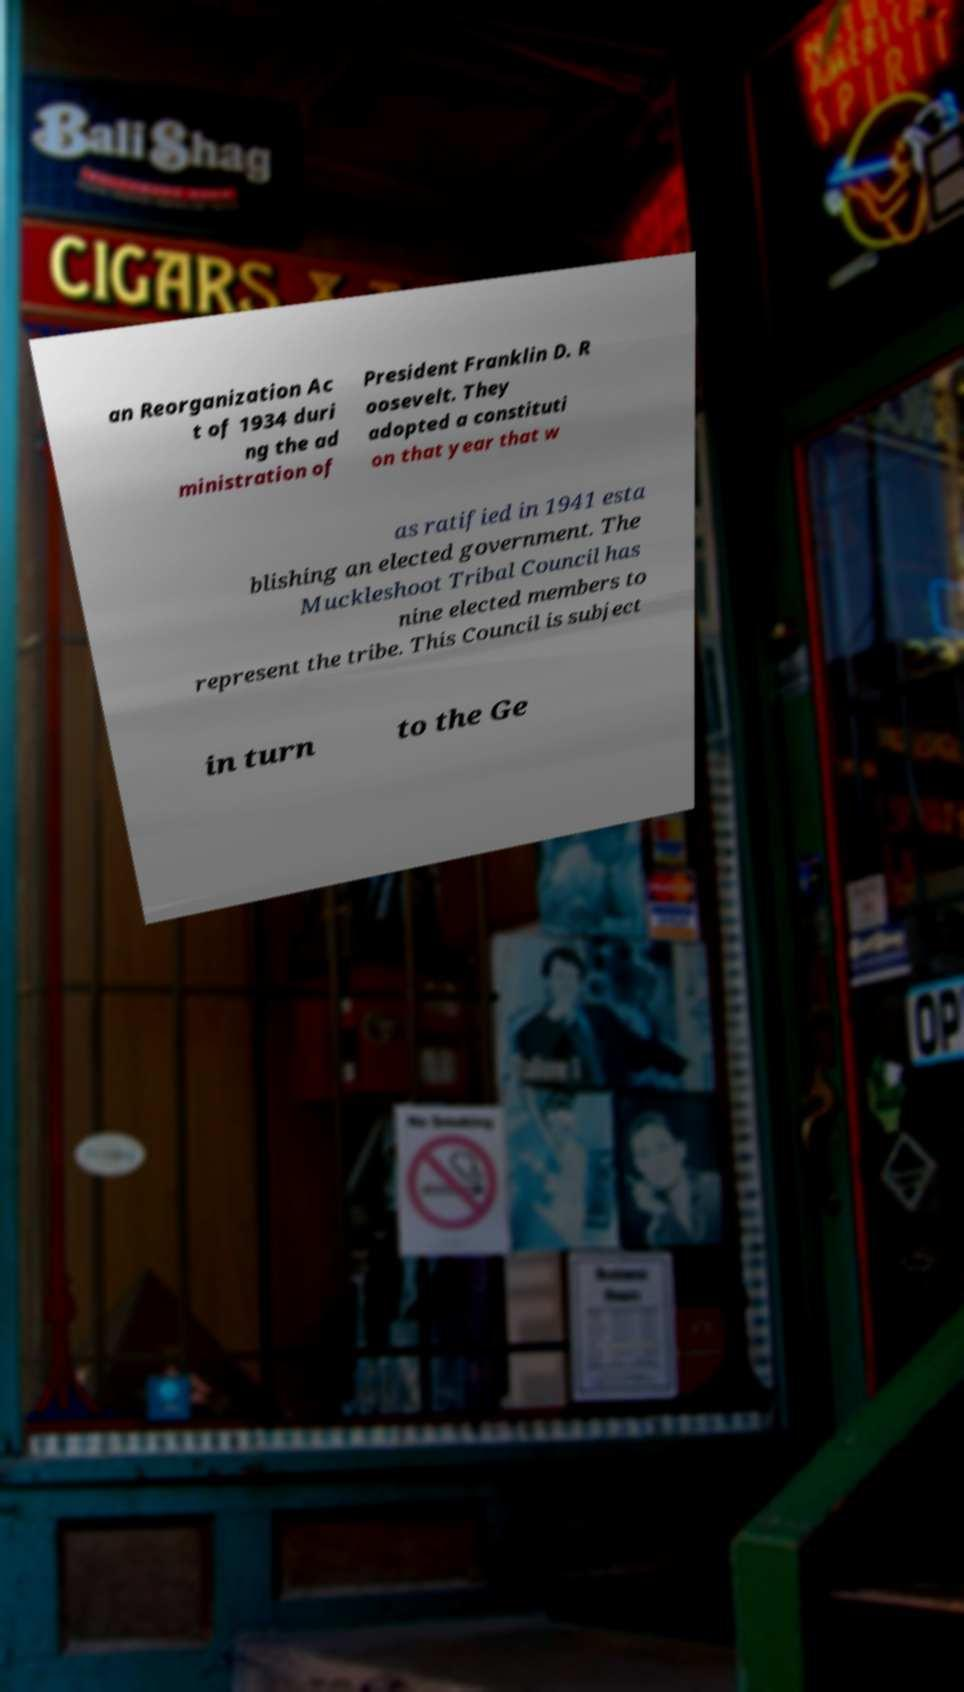What messages or text are displayed in this image? I need them in a readable, typed format. an Reorganization Ac t of 1934 duri ng the ad ministration of President Franklin D. R oosevelt. They adopted a constituti on that year that w as ratified in 1941 esta blishing an elected government. The Muckleshoot Tribal Council has nine elected members to represent the tribe. This Council is subject in turn to the Ge 